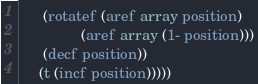Convert code to text. <code><loc_0><loc_0><loc_500><loc_500><_Lisp_>      (rotatef (aref array position)
               (aref array (1- position)))
      (decf position))
     (t (incf position)))))
</code> 